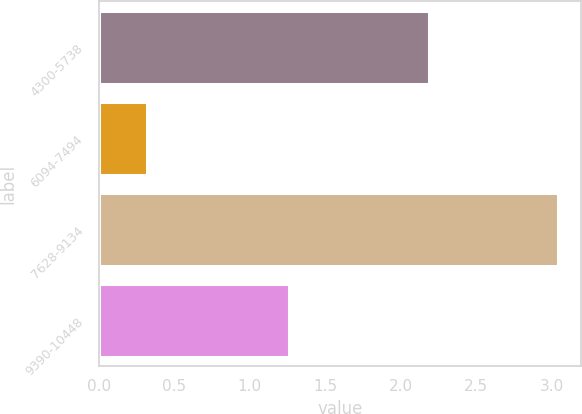Convert chart. <chart><loc_0><loc_0><loc_500><loc_500><bar_chart><fcel>4300-5738<fcel>6094-7494<fcel>7628-9134<fcel>9390-10448<nl><fcel>2.19<fcel>0.32<fcel>3.04<fcel>1.26<nl></chart> 